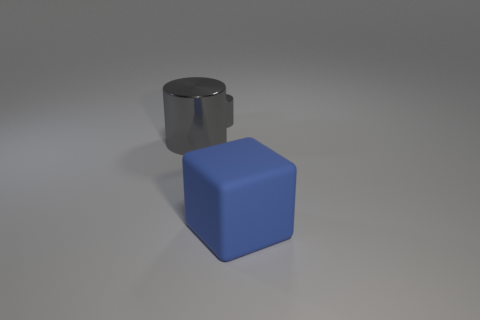Does the tiny gray cylinder have the same material as the large cube?
Provide a succinct answer. No. How big is the thing that is both right of the large gray metal cylinder and behind the big blue thing?
Keep it short and to the point. Small. The big gray metal object has what shape?
Make the answer very short. Cylinder. What number of things are either small shiny cylinders or cylinders that are on the right side of the big metallic object?
Your answer should be very brief. 1. Is the color of the large thing behind the big blue rubber block the same as the small metallic cylinder?
Ensure brevity in your answer.  Yes. There is a object that is in front of the tiny gray cylinder and left of the large cube; what color is it?
Provide a succinct answer. Gray. What material is the big thing behind the matte block?
Offer a terse response. Metal. What is the size of the rubber block?
Offer a terse response. Large. What number of gray things are either small cylinders or metal cylinders?
Ensure brevity in your answer.  2. There is a metallic cylinder that is in front of the gray cylinder behind the big gray cylinder; how big is it?
Give a very brief answer. Large. 